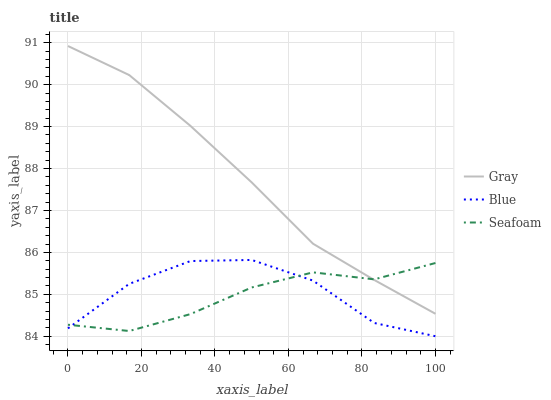Does Seafoam have the minimum area under the curve?
Answer yes or no. Yes. Does Gray have the maximum area under the curve?
Answer yes or no. Yes. Does Gray have the minimum area under the curve?
Answer yes or no. No. Does Seafoam have the maximum area under the curve?
Answer yes or no. No. Is Gray the smoothest?
Answer yes or no. Yes. Is Blue the roughest?
Answer yes or no. Yes. Is Seafoam the smoothest?
Answer yes or no. No. Is Seafoam the roughest?
Answer yes or no. No. Does Blue have the lowest value?
Answer yes or no. Yes. Does Seafoam have the lowest value?
Answer yes or no. No. Does Gray have the highest value?
Answer yes or no. Yes. Does Seafoam have the highest value?
Answer yes or no. No. Is Blue less than Gray?
Answer yes or no. Yes. Is Gray greater than Blue?
Answer yes or no. Yes. Does Seafoam intersect Blue?
Answer yes or no. Yes. Is Seafoam less than Blue?
Answer yes or no. No. Is Seafoam greater than Blue?
Answer yes or no. No. Does Blue intersect Gray?
Answer yes or no. No. 